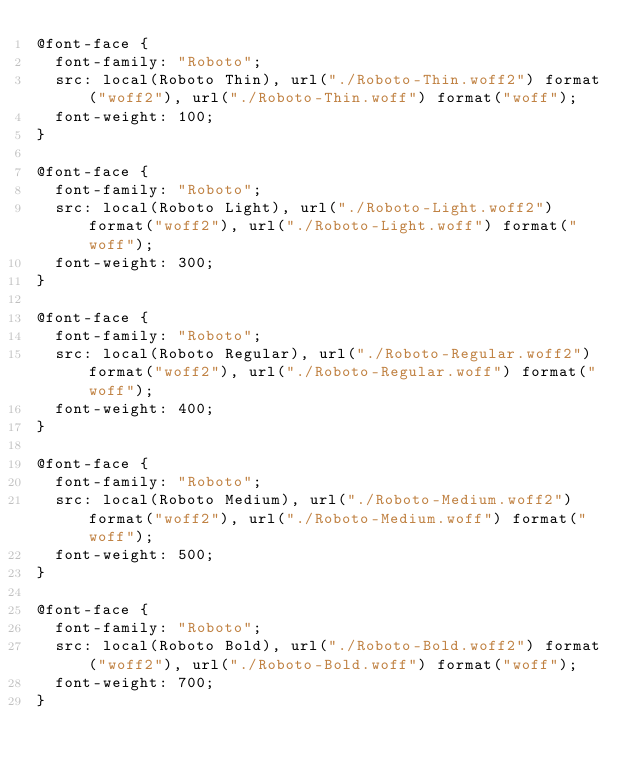Convert code to text. <code><loc_0><loc_0><loc_500><loc_500><_CSS_>@font-face {
	font-family: "Roboto";
	src: local(Roboto Thin), url("./Roboto-Thin.woff2") format("woff2"), url("./Roboto-Thin.woff") format("woff");
	font-weight: 100;
}

@font-face {
	font-family: "Roboto";
	src: local(Roboto Light), url("./Roboto-Light.woff2") format("woff2"), url("./Roboto-Light.woff") format("woff");
	font-weight: 300;
}

@font-face {
	font-family: "Roboto";
	src: local(Roboto Regular), url("./Roboto-Regular.woff2") format("woff2"), url("./Roboto-Regular.woff") format("woff");
	font-weight: 400;
}

@font-face {
	font-family: "Roboto";
	src: local(Roboto Medium), url("./Roboto-Medium.woff2") format("woff2"), url("./Roboto-Medium.woff") format("woff");
	font-weight: 500;
}

@font-face {
	font-family: "Roboto";
	src: local(Roboto Bold), url("./Roboto-Bold.woff2") format("woff2"), url("./Roboto-Bold.woff") format("woff");
	font-weight: 700;
}</code> 